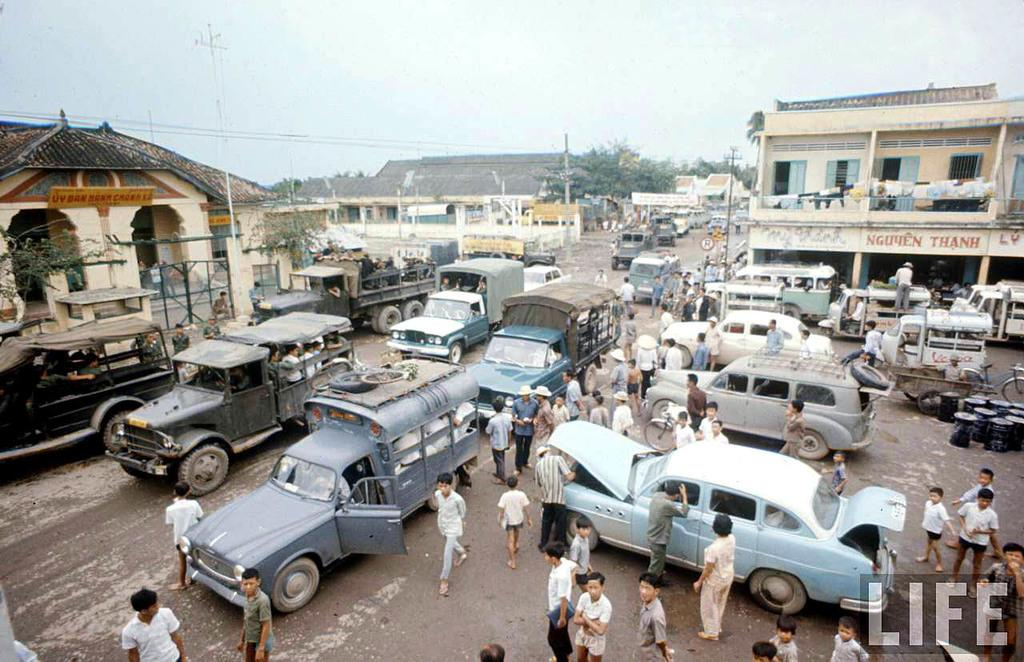What is happening on the road in the image? There are vehicles on the road in the image. What are the people in the image doing? There are people standing and walking in the image. What can be seen in the background of the image? There are sheds, trees, poles, and the sky visible in the background of the image. Are there any girls participating in the protest in the image? There is no protest or girls present in the image. What type of land can be seen in the image? The image does not show any specific type of land; it features a road, vehicles, people, and background elements. 